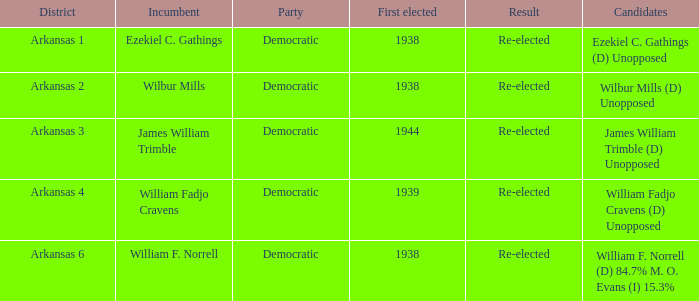0? Democratic. 